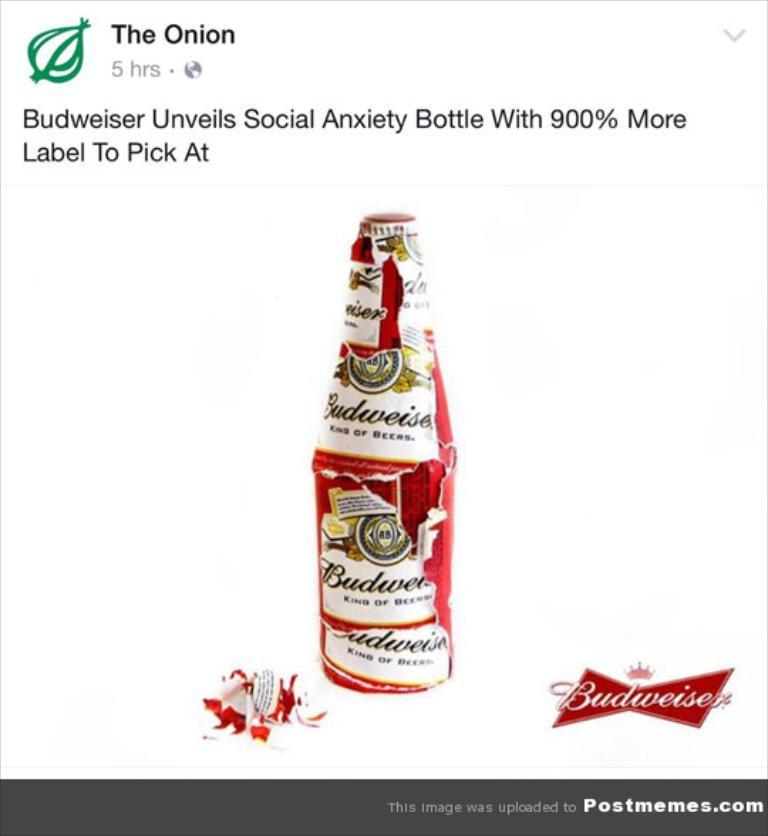<image>
Provide a brief description of the given image. The Onion says that Budweiser has a new Social Anxiety Bottle 